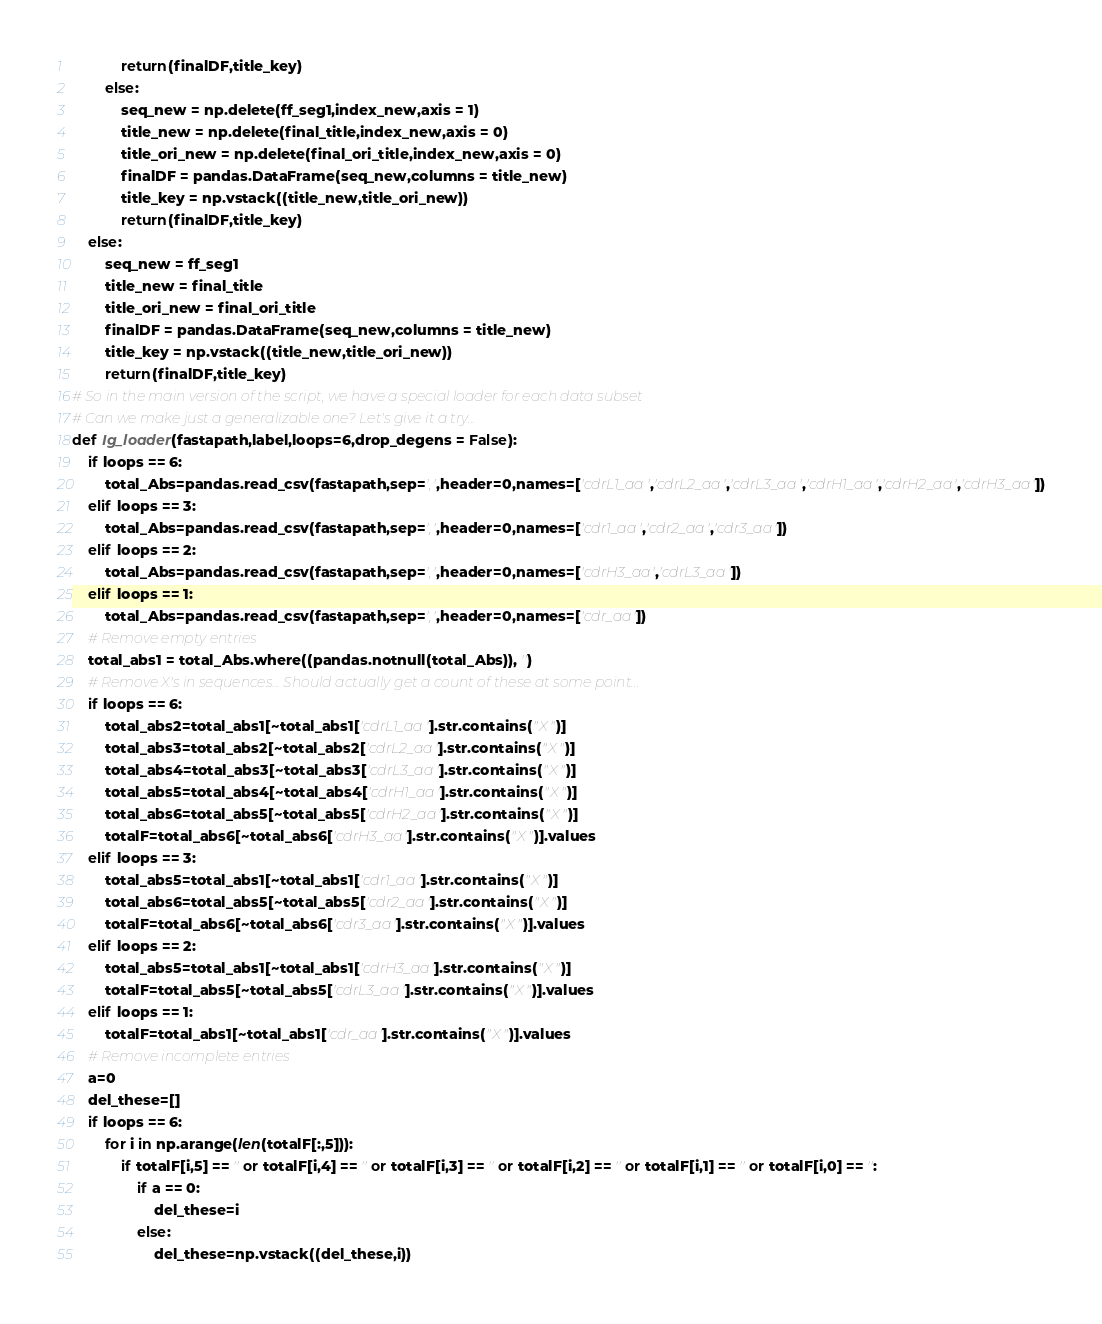Convert code to text. <code><loc_0><loc_0><loc_500><loc_500><_Python_>            return(finalDF,title_key)
        else:
            seq_new = np.delete(ff_seg1,index_new,axis = 1)
            title_new = np.delete(final_title,index_new,axis = 0)
            title_ori_new = np.delete(final_ori_title,index_new,axis = 0)
            finalDF = pandas.DataFrame(seq_new,columns = title_new)
            title_key = np.vstack((title_new,title_ori_new))
            return(finalDF,title_key)
    else:
        seq_new = ff_seg1
        title_new = final_title
        title_ori_new = final_ori_title
        finalDF = pandas.DataFrame(seq_new,columns = title_new)
        title_key = np.vstack((title_new,title_ori_new))
        return(finalDF,title_key)
# So in the main version of the script, we have a special loader for each data subset
# Can we make just a generalizable one? Let's give it a try...
def Ig_loader(fastapath,label,loops=6,drop_degens = False):
    if loops == 6:
        total_Abs=pandas.read_csv(fastapath,sep=',',header=0,names=['cdrL1_aa','cdrL2_aa','cdrL3_aa','cdrH1_aa','cdrH2_aa','cdrH3_aa'])
    elif loops == 3:
        total_Abs=pandas.read_csv(fastapath,sep=',',header=0,names=['cdr1_aa','cdr2_aa','cdr3_aa'])
    elif loops == 2:
        total_Abs=pandas.read_csv(fastapath,sep=',',header=0,names=['cdrH3_aa','cdrL3_aa'])
    elif loops == 1:
        total_Abs=pandas.read_csv(fastapath,sep=',',header=0,names=['cdr_aa'])
    # Remove empty entries
    total_abs1 = total_Abs.where((pandas.notnull(total_Abs)), '')
    # Remove X's in sequences... Should actually get a count of these at some point...
    if loops == 6:
        total_abs2=total_abs1[~total_abs1['cdrL1_aa'].str.contains("X")]
        total_abs3=total_abs2[~total_abs2['cdrL2_aa'].str.contains("X")]
        total_abs4=total_abs3[~total_abs3['cdrL3_aa'].str.contains("X")]
        total_abs5=total_abs4[~total_abs4['cdrH1_aa'].str.contains("X")]
        total_abs6=total_abs5[~total_abs5['cdrH2_aa'].str.contains("X")]
        totalF=total_abs6[~total_abs6['cdrH3_aa'].str.contains("X")].values
    elif loops == 3:
        total_abs5=total_abs1[~total_abs1['cdr1_aa'].str.contains("X")]
        total_abs6=total_abs5[~total_abs5['cdr2_aa'].str.contains("X")]
        totalF=total_abs6[~total_abs6['cdr3_aa'].str.contains("X")].values
    elif loops == 2:
        total_abs5=total_abs1[~total_abs1['cdrH3_aa'].str.contains("X")]
        totalF=total_abs5[~total_abs5['cdrL3_aa'].str.contains("X")].values
    elif loops == 1:
        totalF=total_abs1[~total_abs1['cdr_aa'].str.contains("X")].values
    # Remove incomplete entries
    a=0
    del_these=[]
    if loops == 6:
        for i in np.arange(len(totalF[:,5])):
            if totalF[i,5] == '' or totalF[i,4] == '' or totalF[i,3] == '' or totalF[i,2] == '' or totalF[i,1] == '' or totalF[i,0] == '':
                if a == 0:
                    del_these=i
                else:
                    del_these=np.vstack((del_these,i))</code> 